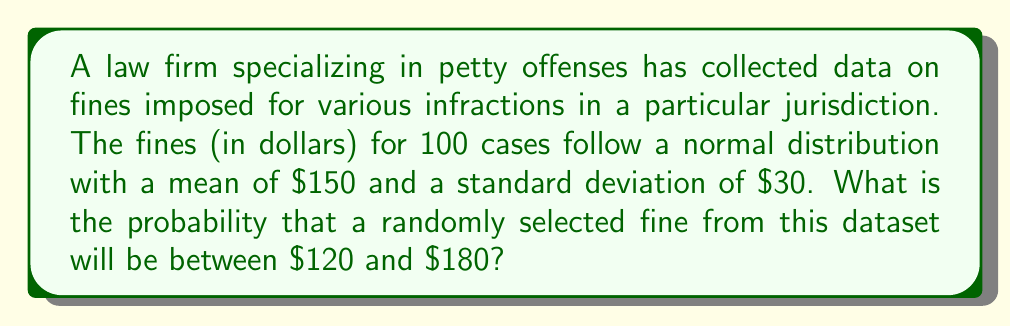Solve this math problem. To solve this problem, we need to use the properties of the normal distribution and the concept of z-scores.

1) First, let's recall that for a normal distribution:
   - Mean (μ) = $150
   - Standard deviation (σ) = $30

2) We need to find P($120 < X < $180), where X is the random variable representing the fine amount.

3) To standardize these values, we need to convert them to z-scores using the formula:
   $z = \frac{x - \mu}{\sigma}$

4) For the lower bound ($120):
   $z_1 = \frac{120 - 150}{30} = -1$

5) For the upper bound ($180):
   $z_2 = \frac{180 - 150}{30} = 1$

6) Now, we need to find P(-1 < Z < 1), where Z is the standard normal variable.

7) Using a standard normal table or calculator, we can find:
   P(Z < 1) = 0.8413
   P(Z < -1) = 0.1587

8) The probability we're looking for is:
   P(-1 < Z < 1) = P(Z < 1) - P(Z < -1)
                 = 0.8413 - 0.1587
                 = 0.6826

Therefore, the probability that a randomly selected fine will be between $120 and $180 is approximately 0.6826 or 68.26%.
Answer: 0.6826 or 68.26% 